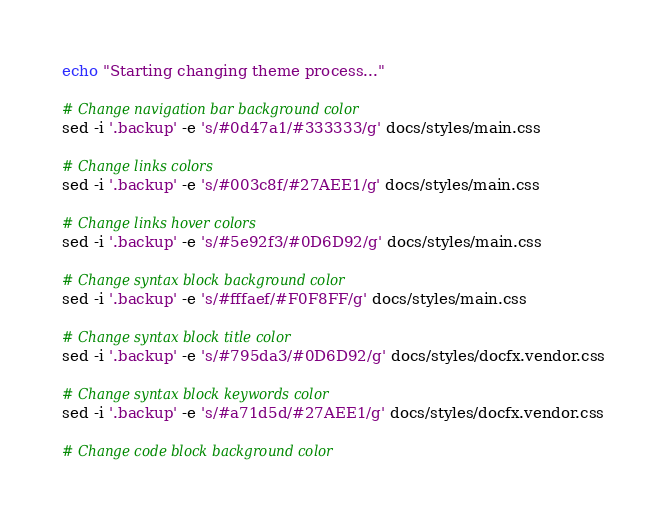Convert code to text. <code><loc_0><loc_0><loc_500><loc_500><_Bash_>echo "Starting changing theme process..."

# Change navigation bar background color
sed -i '.backup' -e 's/#0d47a1/#333333/g' docs/styles/main.css

# Change links colors
sed -i '.backup' -e 's/#003c8f/#27AEE1/g' docs/styles/main.css

# Change links hover colors
sed -i '.backup' -e 's/#5e92f3/#0D6D92/g' docs/styles/main.css

# Change syntax block background color
sed -i '.backup' -e 's/#fffaef/#F0F8FF/g' docs/styles/main.css

# Change syntax block title color
sed -i '.backup' -e 's/#795da3/#0D6D92/g' docs/styles/docfx.vendor.css

# Change syntax block keywords color
sed -i '.backup' -e 's/#a71d5d/#27AEE1/g' docs/styles/docfx.vendor.css

# Change code block background color</code> 